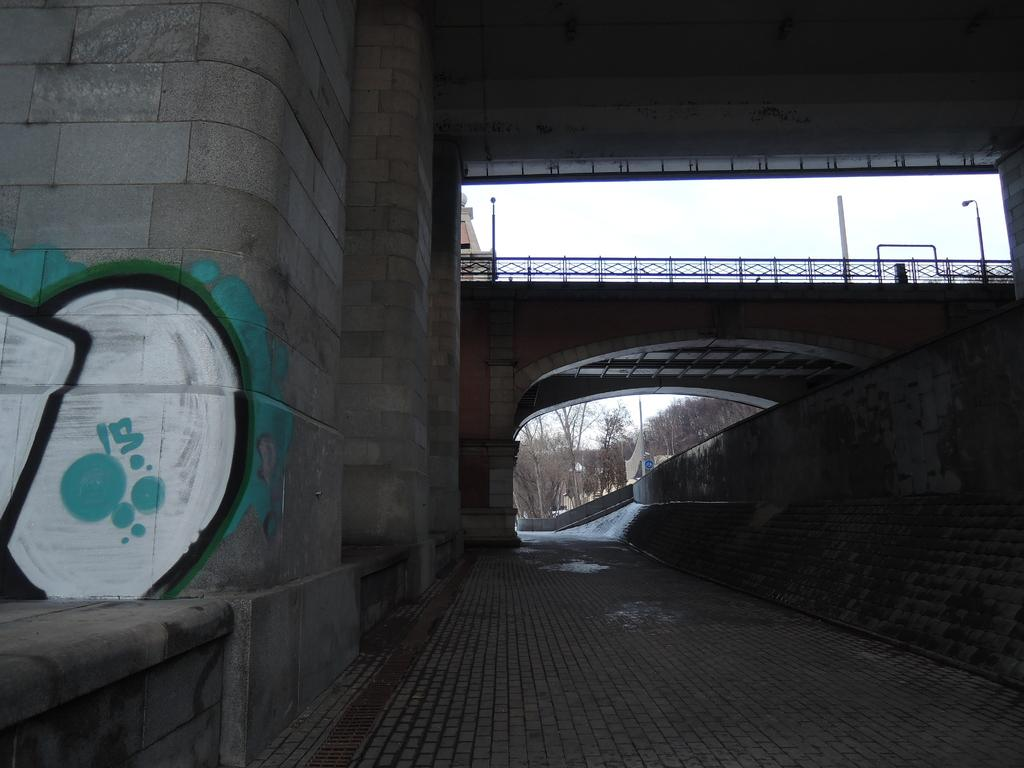What is the main structure in the image? There is a bridge at the center of the image. What is located beneath the bridge? There is a road beneath the bridge. What can be seen in the background of the image? There are trees and the sky visible in the background of the image. What type of silk is being used to create the river in the image? There is no river present in the image, and silk is not used to create any elements in the image. Can you hear the people laughing in the image? There are no people or sounds of laughter depicted in the image. 